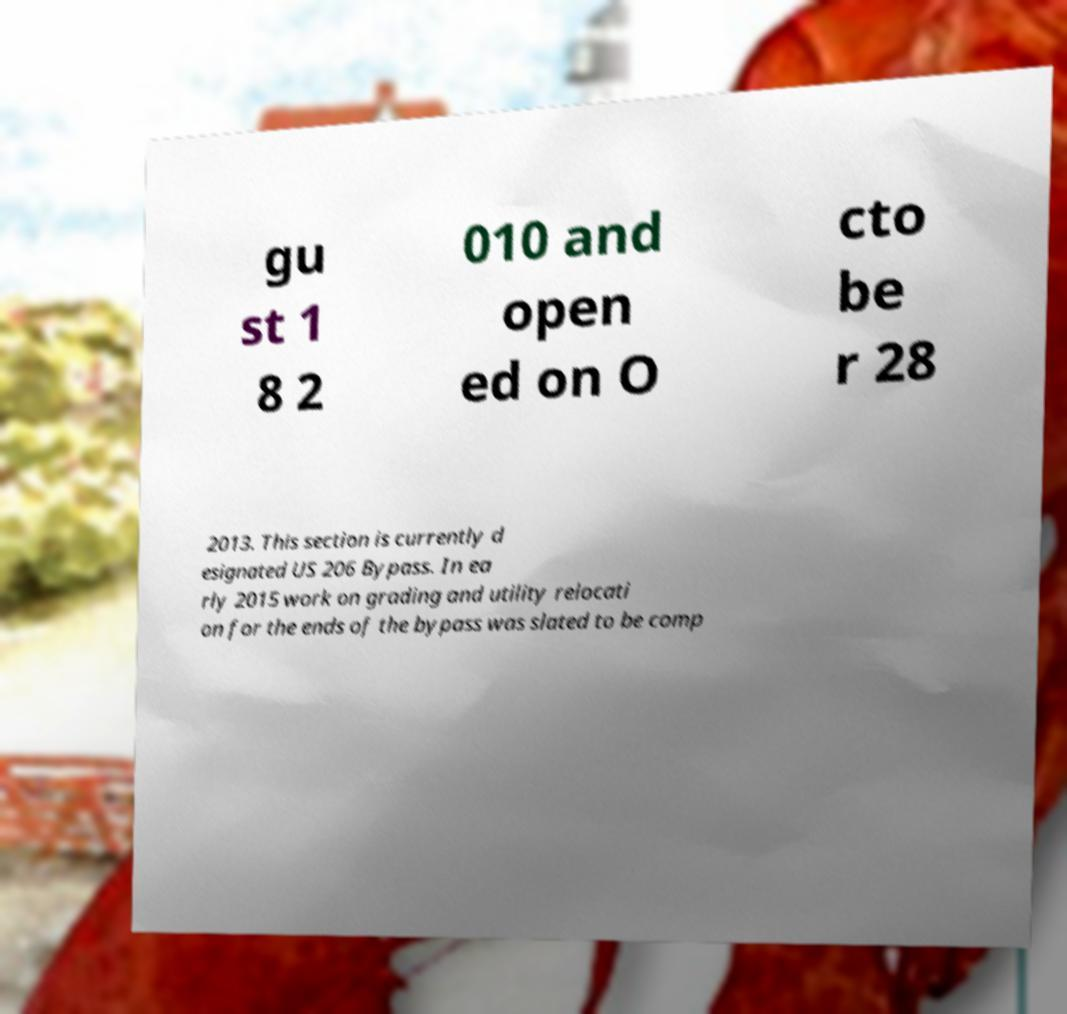Could you extract and type out the text from this image? gu st 1 8 2 010 and open ed on O cto be r 28 2013. This section is currently d esignated US 206 Bypass. In ea rly 2015 work on grading and utility relocati on for the ends of the bypass was slated to be comp 